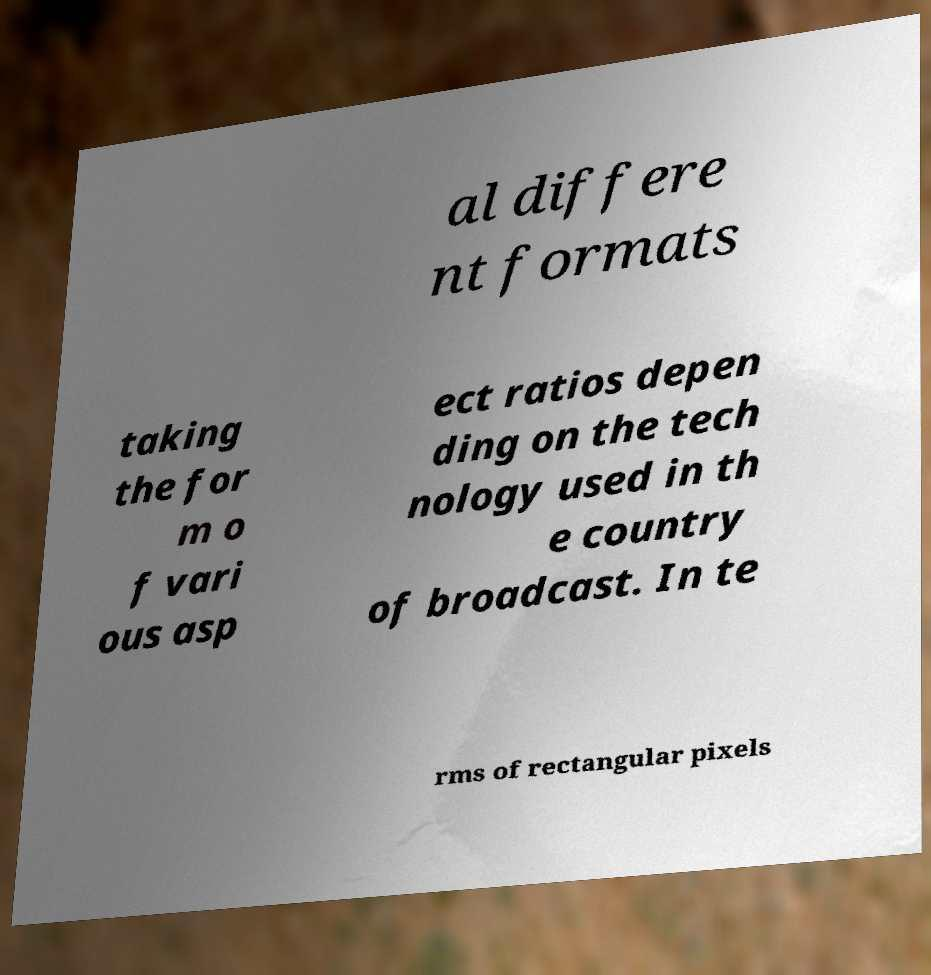Can you read and provide the text displayed in the image?This photo seems to have some interesting text. Can you extract and type it out for me? al differe nt formats taking the for m o f vari ous asp ect ratios depen ding on the tech nology used in th e country of broadcast. In te rms of rectangular pixels 